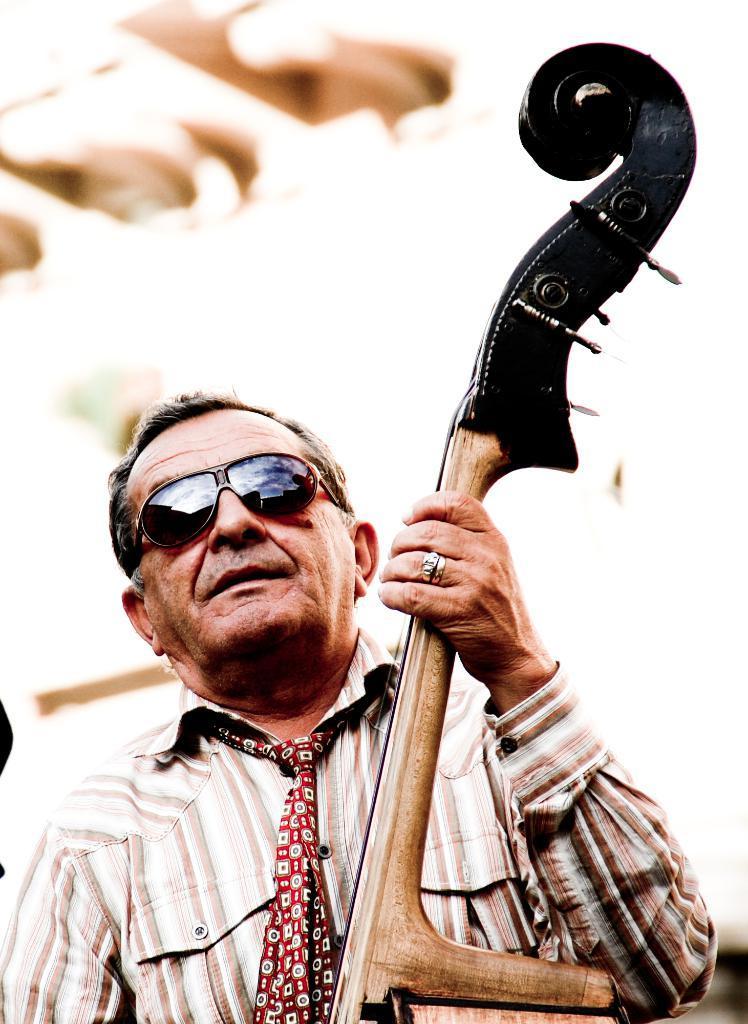Can you describe this image briefly? In the image there is an old man,he is playing a music instrument. The man is wearing a cream and white color shirt,goggles and the background of the man is blur. 